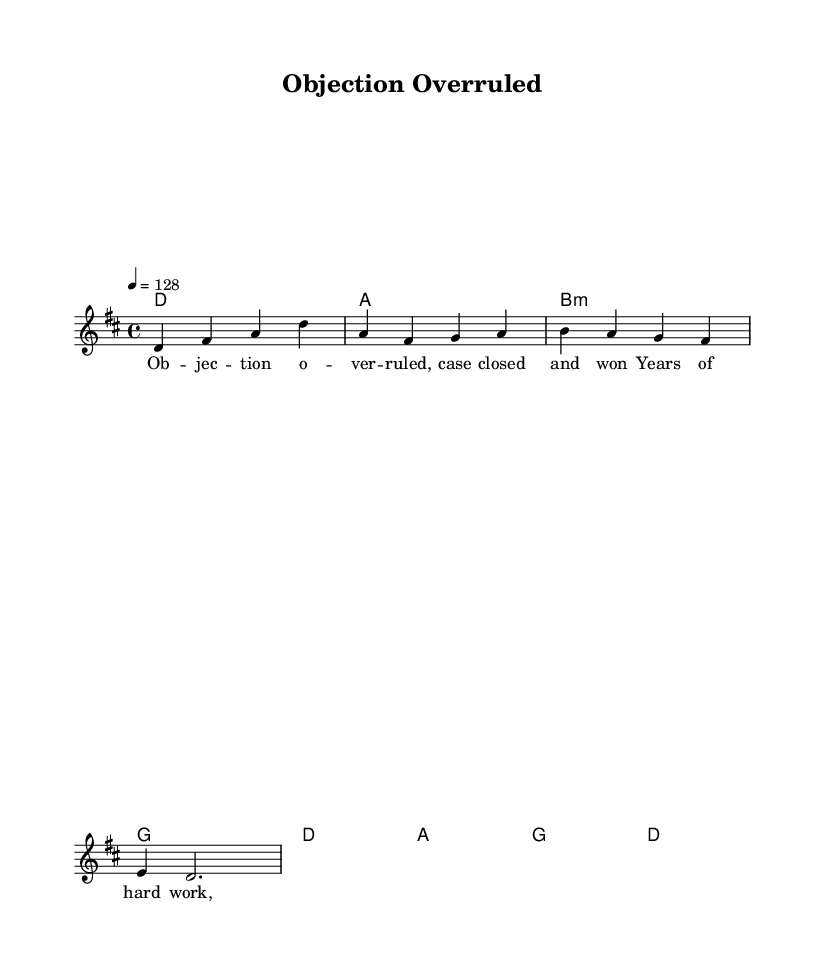What is the key signature of this music? The key signature is D major, indicated by the presence of two sharps (C# and F#) in the key signature at the beginning of the staff.
Answer: D major What is the time signature of this piece? The time signature is 4/4, which is shown at the beginning of the staff. It indicates that there are four beats in a measure and a quarter note receives one beat.
Answer: 4/4 What is the indicated tempo? The indicated tempo is 128 beats per minute, specified by the "4 = 128" marking at the beginning of the score. This indicates how fast the piece should be played.
Answer: 128 How many measures are in the harmony section? The harmony section has four measures as indicated by the chord symbols shown. Each chord symbol corresponds to one measure, and there are four distinct symbols displayed.
Answer: Four What is the main lyrical theme of this piece? The main lyrical theme is centered around overcoming challenges and achieving success, illustrated by phrases like "Objection Overruled" and references to years of hard work leading to justice.
Answer: Success Which chord appears first in the harmony progression? The first chord in the harmony progression is D major, indicated as "d1" at the start of the chord section. This signifies the harmony that accompanies the melody initially.
Answer: D What type of song structure does this piece represent? This piece can be categorized as a power anthem due to its uplifting message celebrating achievement and professional victories through its lyrics and energetic melody.
Answer: Power anthem 